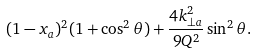Convert formula to latex. <formula><loc_0><loc_0><loc_500><loc_500>( 1 - x _ { a } ) ^ { 2 } ( 1 + \cos ^ { 2 } \theta ) + \frac { 4 { k } _ { \perp a } ^ { 2 } } { 9 Q ^ { 2 } } \sin ^ { 2 } \theta .</formula> 